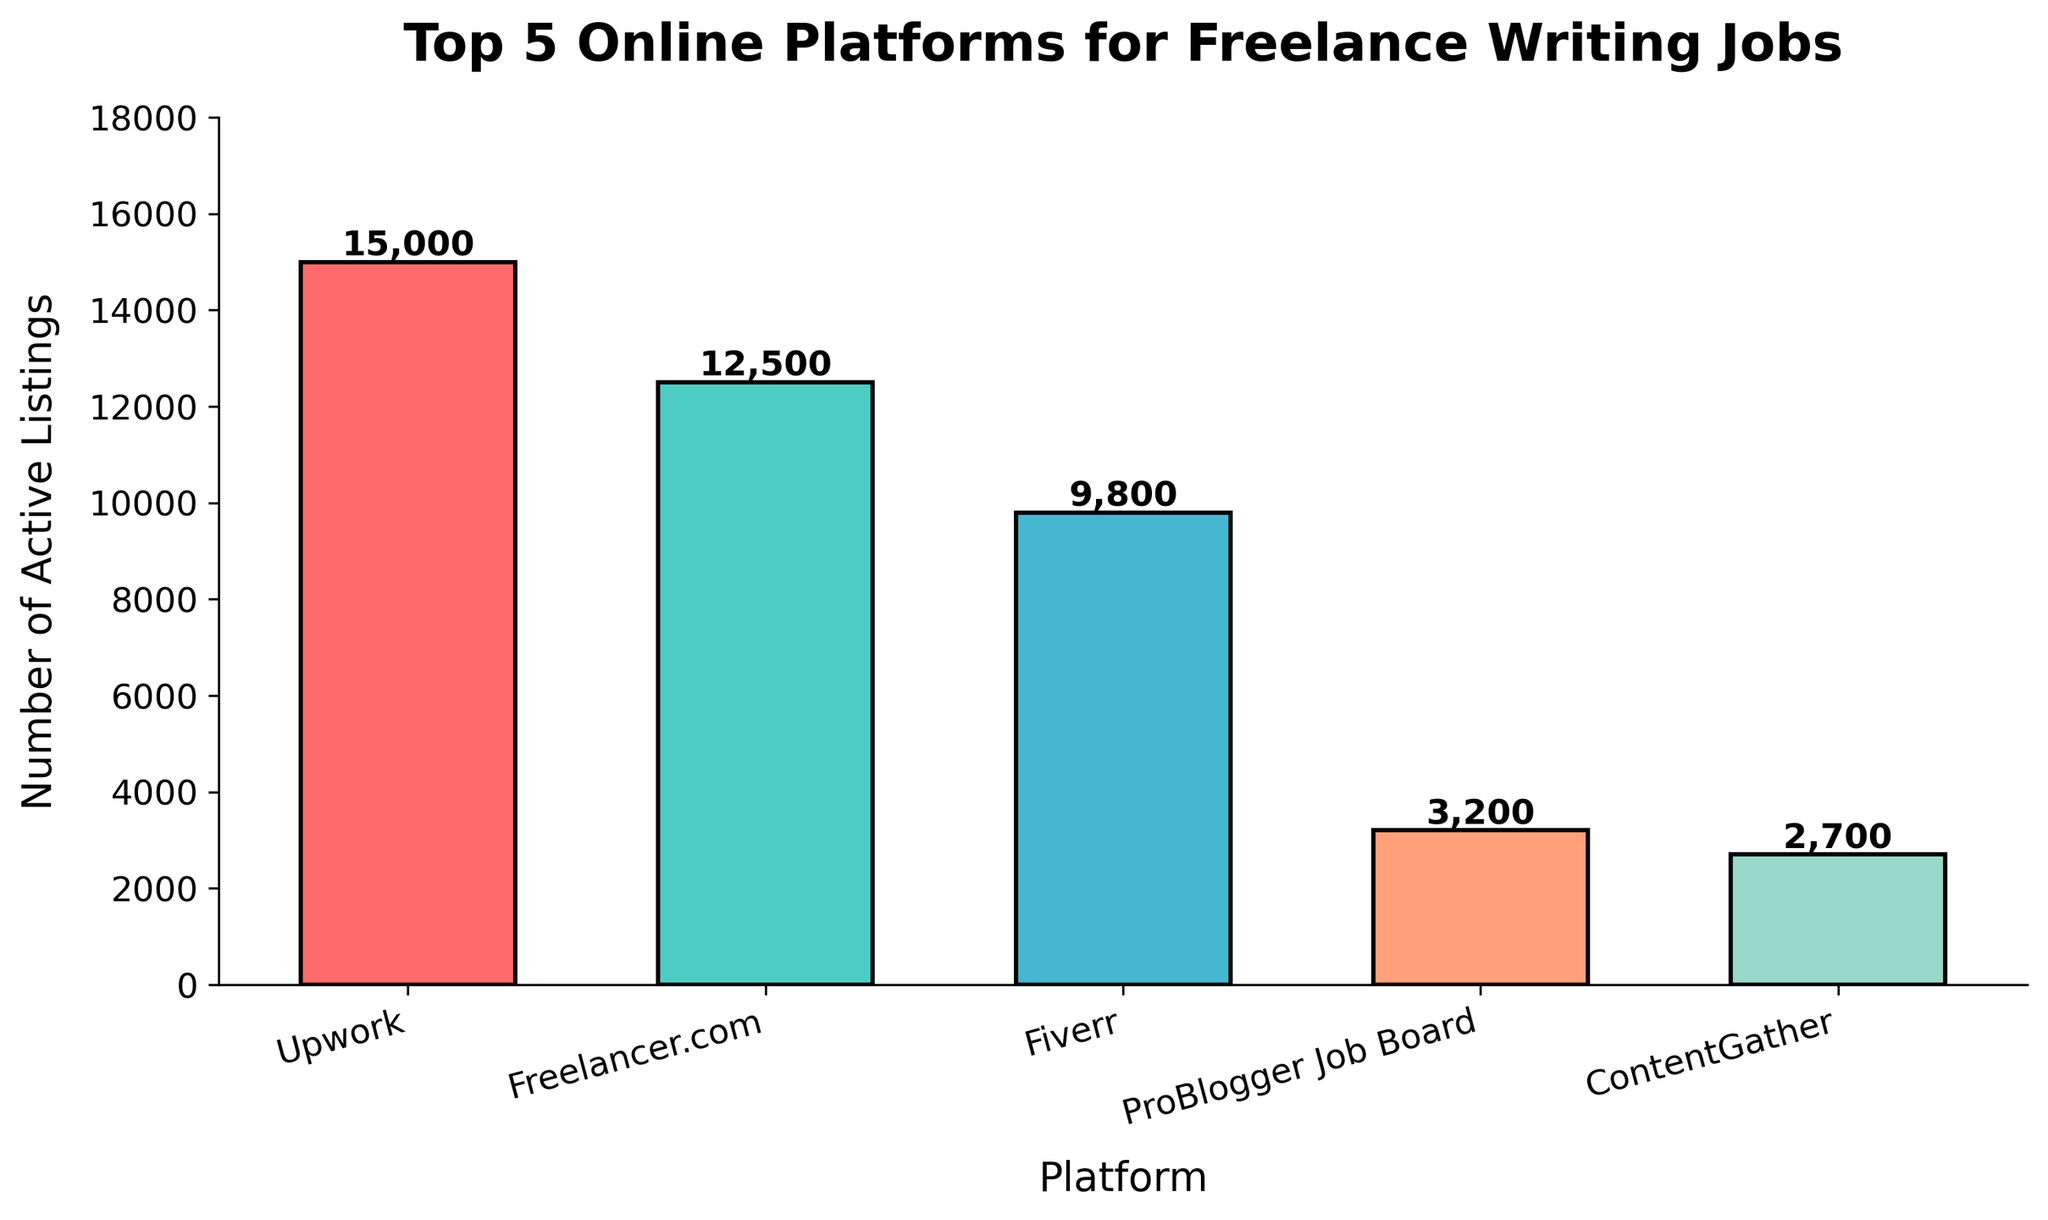Which platform has the highest number of active listings? The platform with the highest bar on the graph represents the one with the most active listings. In the figure, Upwork has the tallest bar.
Answer: Upwork What is the total number of active listings across all platforms? To get the total, sum up the active listings for all platforms: Upwork (15,000), Freelancer.com (12,500), Fiverr (9,800), ProBlogger Job Board (3,200), ContentGather (2,700). The total is 15,000 + 12,500 + 9,800 + 3,200 + 2,700.
Answer: 43,200 How many more active listings does Upwork have compared to ContentGather? Subtract the active listings of ContentGather from those of Upwork: 15,000 - 2,700.
Answer: 12,300 Which platform has the second highest number of active listings? The platform with the second tallest bar after Upwork represents the one with the second highest number of active listings. In the figure, Freelancer.com has the second tallest bar.
Answer: Freelancer.com What is the difference in active listings between Fiverr and ProBlogger Job Board? Subtract the active listings of ProBlogger Job Board from those of Fiverr: 9,800 - 3,200.
Answer: 6,600 Which platform has the lowest number of active listings? The platform with the shortest bar on the graph represents the one with the lowest number of active listings. In the figure, ContentGather has the shortest bar.
Answer: ContentGather If you combine the active listings of Freelancer.com and ProBlogger Job Board, would their total exceed that of Upwork? First combine the listings of Freelancer.com and ProBlogger Job Board: 12,500 + 3,200 = 15,700. Then compare it to Upwork’s listings: 15,700 > 15,000.
Answer: Yes What is the average number of active listings for the listed platforms? To find the average, first sum up the active listings for all platforms: 15,000 + 12,500 + 9,800 + 3,200 + 2,700 = 43,200. Then divide by the number of platforms, which is 5. So: 43,200 / 5.
Answer: 8,640 How does the number of active listings for Fiverr compare to that for Upwork? Compare the active listings directly: Fiverr has 9,800 and Upwork has 15,000, so Fiverr has fewer than Upwork.
Answer: Less Which platform color is represented by the highest bar in the chart? Identify the color associated with the tallest bar. The bar for Upwork, which is the tallest, is colored red.
Answer: Red 